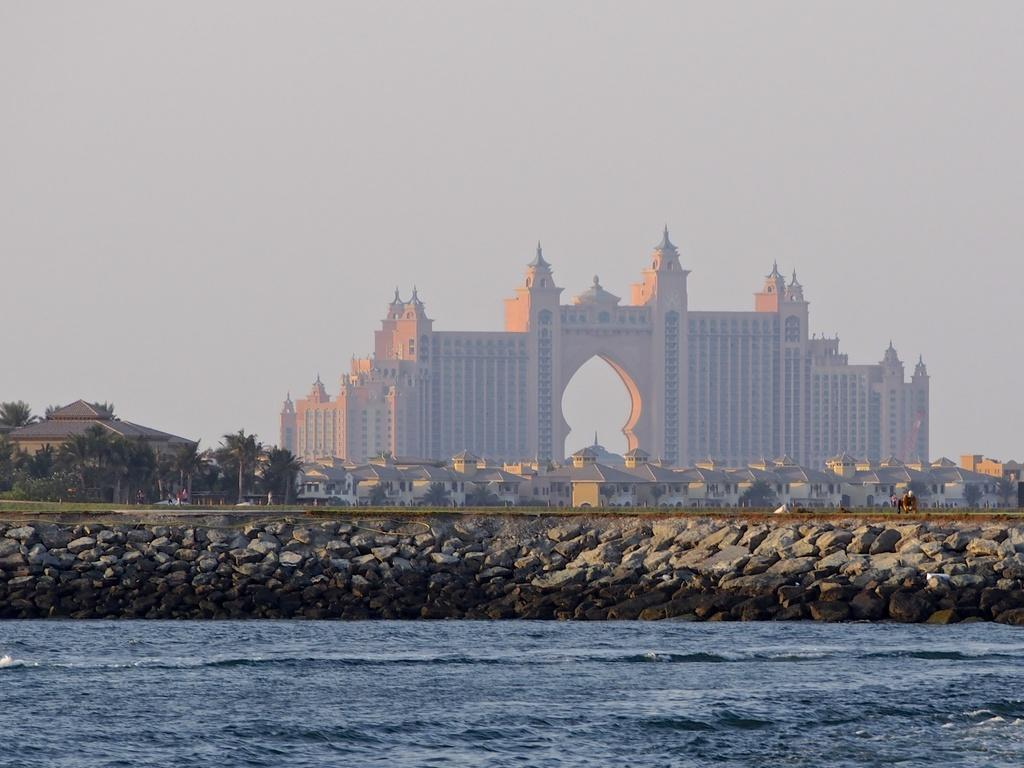What type of structures can be seen in the image? There are houses and buildings in the image. What natural elements are present in the image? There are trees in the image. Can you describe the water flow visible in the image? Yes, there is water flow visible in the image. What type of skirt is being worn by the dock in the image? There is no dock present in the image, and therefore no skirt can be associated with it. 